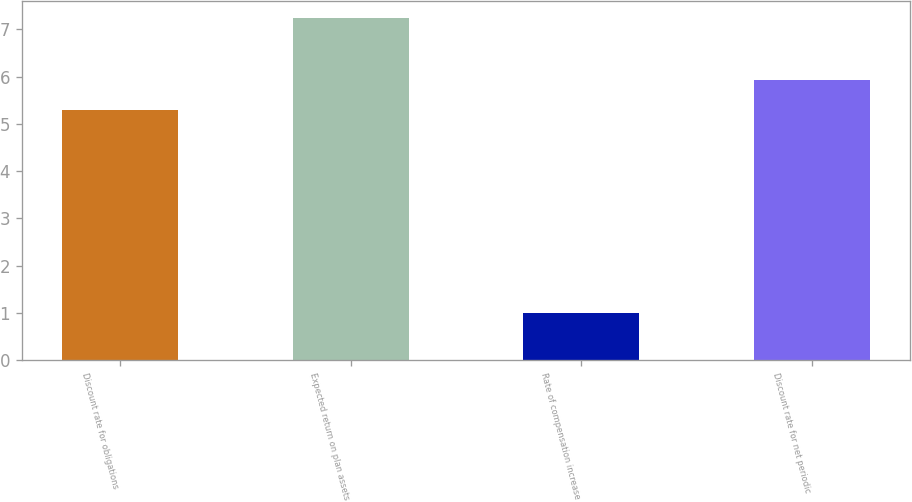Convert chart. <chart><loc_0><loc_0><loc_500><loc_500><bar_chart><fcel>Discount rate for obligations<fcel>Expected return on plan assets<fcel>Rate of compensation increase<fcel>Discount rate for net periodic<nl><fcel>5.3<fcel>7.25<fcel>1<fcel>5.92<nl></chart> 